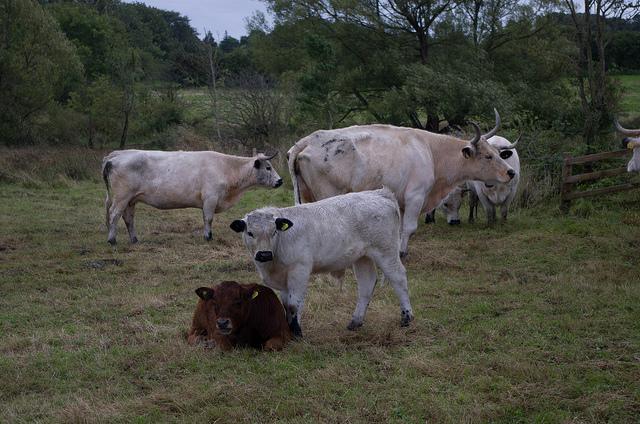How many of the cattle have horns?
Be succinct. 4. How many cattle are in the picture?
Answer briefly. 5. What is the color of the smallest cow?
Concise answer only. Brown. Are the cows the same color?
Be succinct. No. What animal is this?
Quick response, please. Cow. How many of the animals shown are being raised for their meat?
Write a very short answer. 5. Are there three cows in the picture?
Write a very short answer. Yes. How many animals are in this picture?
Answer briefly. 7. What animals are this?
Quick response, please. Cows. Are these cows clean?
Answer briefly. Yes. Is the calf hungry?
Be succinct. No. What colors are the cows?
Keep it brief. Brown. Is the grass all green?
Answer briefly. No. What are the cattle for?
Write a very short answer. Food. 